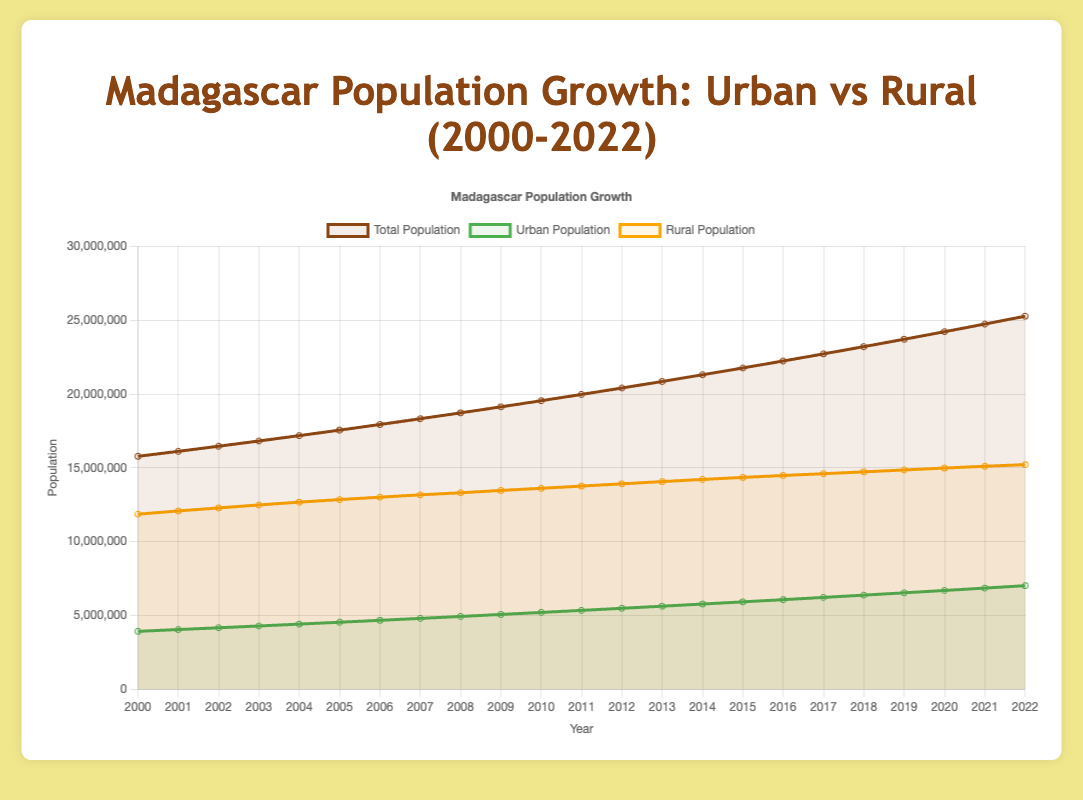What is the difference between the urban population and the rural population in the year 2005? In 2005, the rural population is 12,846,315, and the urban population is 4,537,144. The difference is calculated by subtracting the urban population from the rural population: 12,846,315 - 4,537,144 = 8,309,171.
Answer: 8,309,171 Which year shows the highest total population, and what is that population? The highest total population is in the year 2022. By looking at the figure, we can see that 2022 has the highest point on the total population curve. The population in that year is 25,269,281.
Answer: 2022, 25,269,281 How many years did it take for the urban population to increase from around 4 million to around 6 million? The urban population was around 4 million in 2001 and reached around 6 million in 2016. To find the number of years it took, subtract the starting year from the ending year: 2016 - 2001 = 15 years.
Answer: 15 years What is the average rural population from 2000 to 2010? To find the average, sum the rural populations from 2000 to 2010 and divide by the number of years (11). The sum is 11857243 + 12075642 + 12280727 + 12482514 + 12671036 + 12846315 + 13008385 + 13167280 + 13309028 + 13465670 + 13611544 = 142475984. Divide by 11 to get the average: 142475984 / 11 = 12,952,362.18.
Answer: 12,952,362.18 In which year did the urban population surpass 6 million, and how does this compare to the rural population that year? The urban population first surpassed 6 million in the year 2016. In that year, the urban population was 6,066,594, and the rural population was 14,478,456, which means the rural population was still significantly larger than the urban population.
Answer: 2016; rural population was larger What was the total population increase from 2000 to 2020? The total population in 2000 was 15,777,657, and in 2020, it was 24,219,514. The increase is found by subtracting the initial population from the final population: 24,219,514 - 15,777,657 = 8,441,857.
Answer: 8,441,857 How does the urban population growth rate from 2000 to 2010 compare to the rural population growth rate in the same period? The urban population in 2000 was 3,920,414 and in 2010 it was 5,201,096, resulting in an increase of 1,280,682. The rural population in 2000 was 11,857,243 and in 2010 it was 13,611,544, resulting in an increase of 1,754,301. The urban growth rate is (5,201,096 - 3,920,414) / 3,920,414 * 100 = 32.67%. The rural growth rate is (13,611,544 - 11,857,243) / 11,857,243 * 100 = 14.79%. Thus, the urban population growth rate was higher.
Answer: Urban: 32.67%, Rural: 14.79%, Urban is higher What is the proportion of the urban population to the total population in 2022? The population in 2022 is split as follows: total population: 25,269,281, urban population: 7,014,464. The proportion is calculated by dividing the urban population by the total population: 7,014,464 / 25,269,281 = 0.2777. In percentage, this is 27.77%.
Answer: 27.77% Which year saw the smallest increase in total population compared to the previous year? By examining the slope of the total population curve and the data points, the year with the smallest increase can be identified. Between 2006 and 2007, the total population increased from 17,934,395 to 18,324,079, an increase of 389,684, which is relatively smaller compared to other yearly increases.
Answer: 2007 By how much did the rural population grow in total from 2000 to 2022? The rural population in 2000 was 11,857,243, and in 2022 it was 15,214,817. The growth can be calculated by subtracting the initial population from the final population: 15,214,817 - 11,857,243 = 3,357,574.
Answer: 3,357,574 